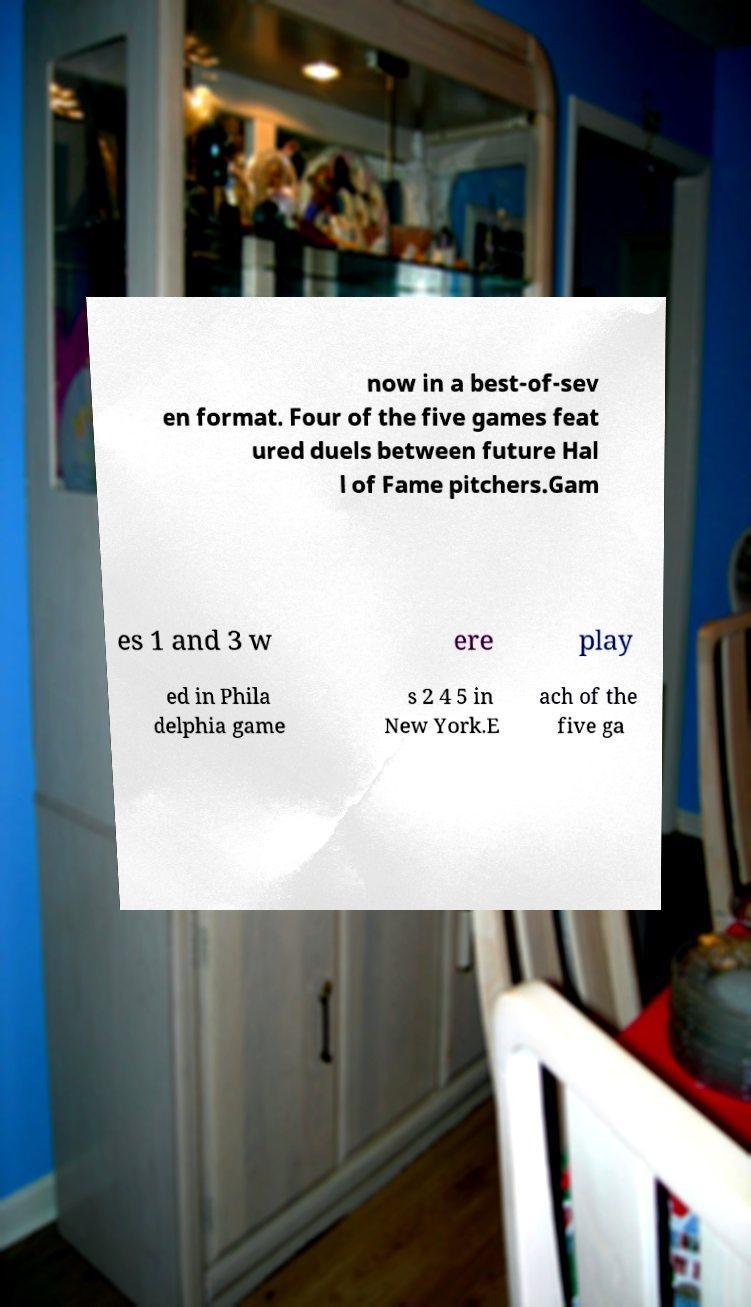I need the written content from this picture converted into text. Can you do that? now in a best-of-sev en format. Four of the five games feat ured duels between future Hal l of Fame pitchers.Gam es 1 and 3 w ere play ed in Phila delphia game s 2 4 5 in New York.E ach of the five ga 